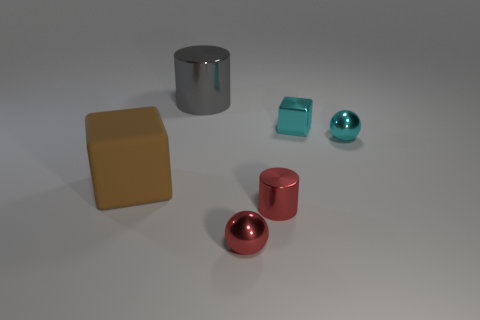Add 4 red rubber things. How many objects exist? 10 Subtract 1 cylinders. How many cylinders are left? 1 Subtract all cubes. How many objects are left? 4 Subtract all cyan metal spheres. Subtract all big things. How many objects are left? 3 Add 3 big things. How many big things are left? 5 Add 3 small red cylinders. How many small red cylinders exist? 4 Subtract 1 brown cubes. How many objects are left? 5 Subtract all cyan cylinders. Subtract all red spheres. How many cylinders are left? 2 Subtract all green cylinders. How many blue balls are left? 0 